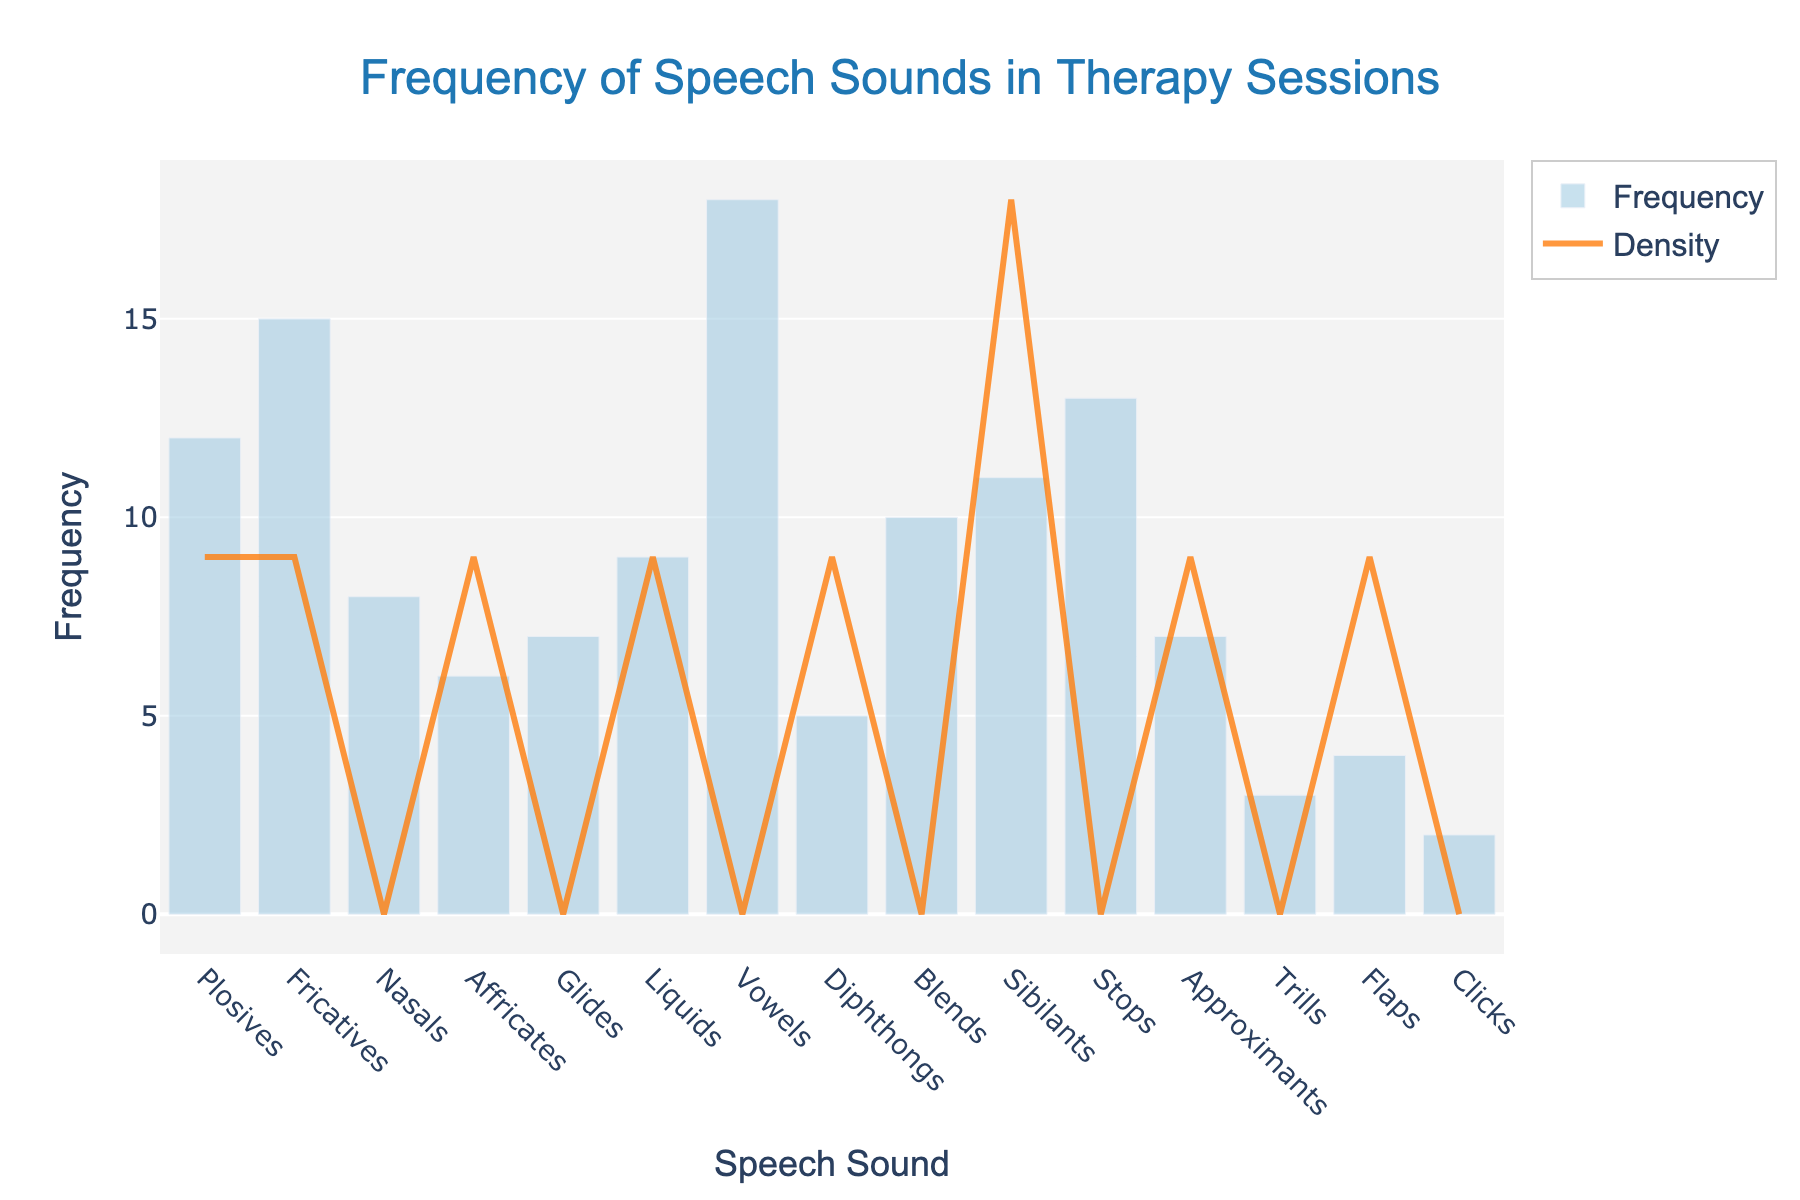What's the title of the figure? The title is placed at the top of the figure and is clearly marked in a larger and distinct font.
Answer: Frequency of Speech Sounds in Therapy Sessions What does the x-axis represent? The x-axis labels each category along the bottom of the figure. In this case, it names each speech sound category.
Answer: Speech Sound Which speech sound has the highest frequency? You can identify the highest bar in the histogram which corresponds to the speech sound with the highest value.
Answer: Vowels Which speech sound has the lowest frequency? Identifying the shortest bar in the histogram will show the speech sound with the lowest value.
Answer: Clicks What is the frequency of "Stops"? Locate the bar labeled "Stops" and read its height to determine the frequency.
Answer: 13 What is the combined frequency of "Plosives" and "Nasals"? Find the bars labeled "Plosives" and "Nasals", add their heights together: 12 (Plosives) + 8 (Nasals) = 20.
Answer: 20 Which speech sound categories have a frequency greater than 10? Review the histogram bars and note which ones exceed the height corresponding to 10.
Answer: Plosives, Fricatives, Vowels, Stops Is the KDE curve higher at "Fricatives" or "Liquids"? Compare the height of the density curve (KDE) at the positions corresponding to "Fricatives" and "Liquids".
Answer: Fricatives What is the average frequency of "Glides", "Liquids", and "Sibilants"? Sum the frequencies of these three categories and divide by the number of categories: (7 + 9 + 11)/3 = 27/3 = 9.
Answer: 9 Which speech sound categories have a frequency that lies between the heights of the KDE curve at "Nasals" and "Glides"? Compare the heights of the KDE curve at these two points, then find bars that fall within this range.
Answer: Affricates, Glides, Liquids, Nasals 